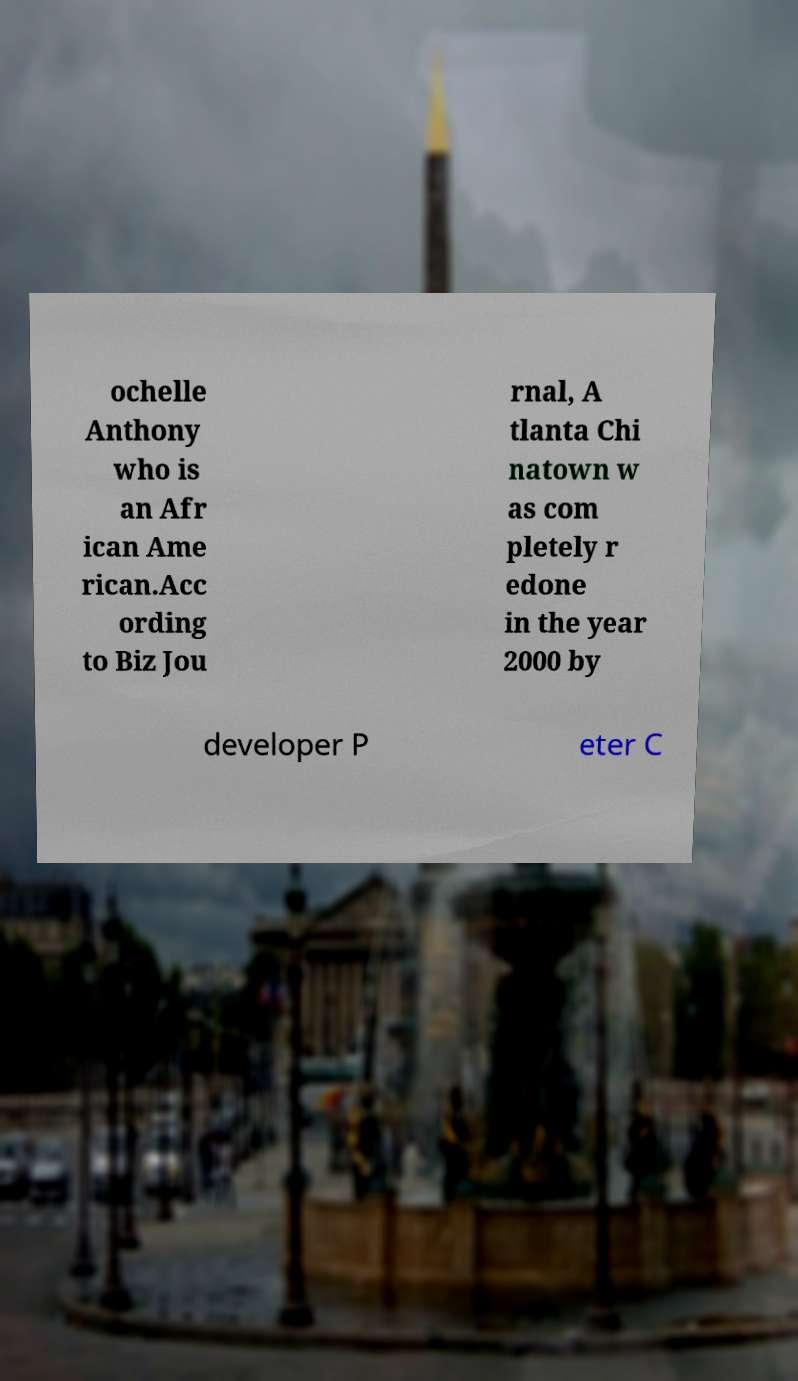Can you read and provide the text displayed in the image?This photo seems to have some interesting text. Can you extract and type it out for me? ochelle Anthony who is an Afr ican Ame rican.Acc ording to Biz Jou rnal, A tlanta Chi natown w as com pletely r edone in the year 2000 by developer P eter C 